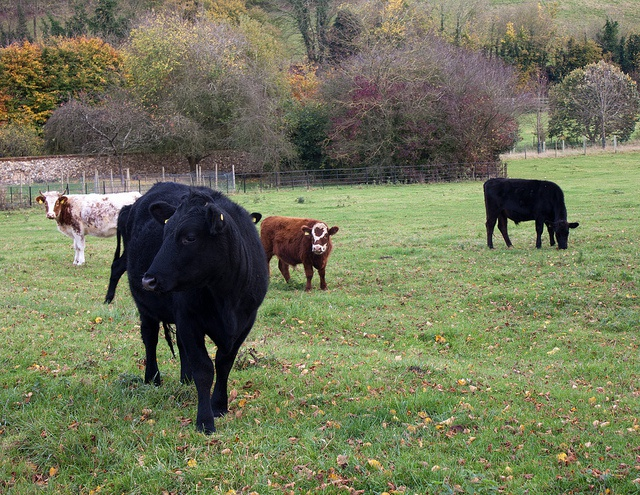Describe the objects in this image and their specific colors. I can see cow in gray, black, and olive tones, cow in gray, black, and olive tones, cow in gray, maroon, black, and brown tones, and cow in gray, lavender, darkgray, and pink tones in this image. 